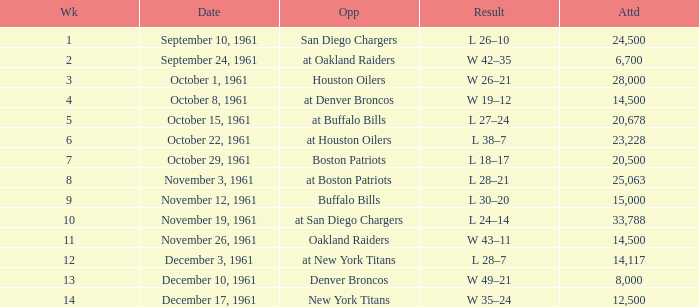What is the top attendance for weeks past 2 on october 29, 1961? 20500.0. 